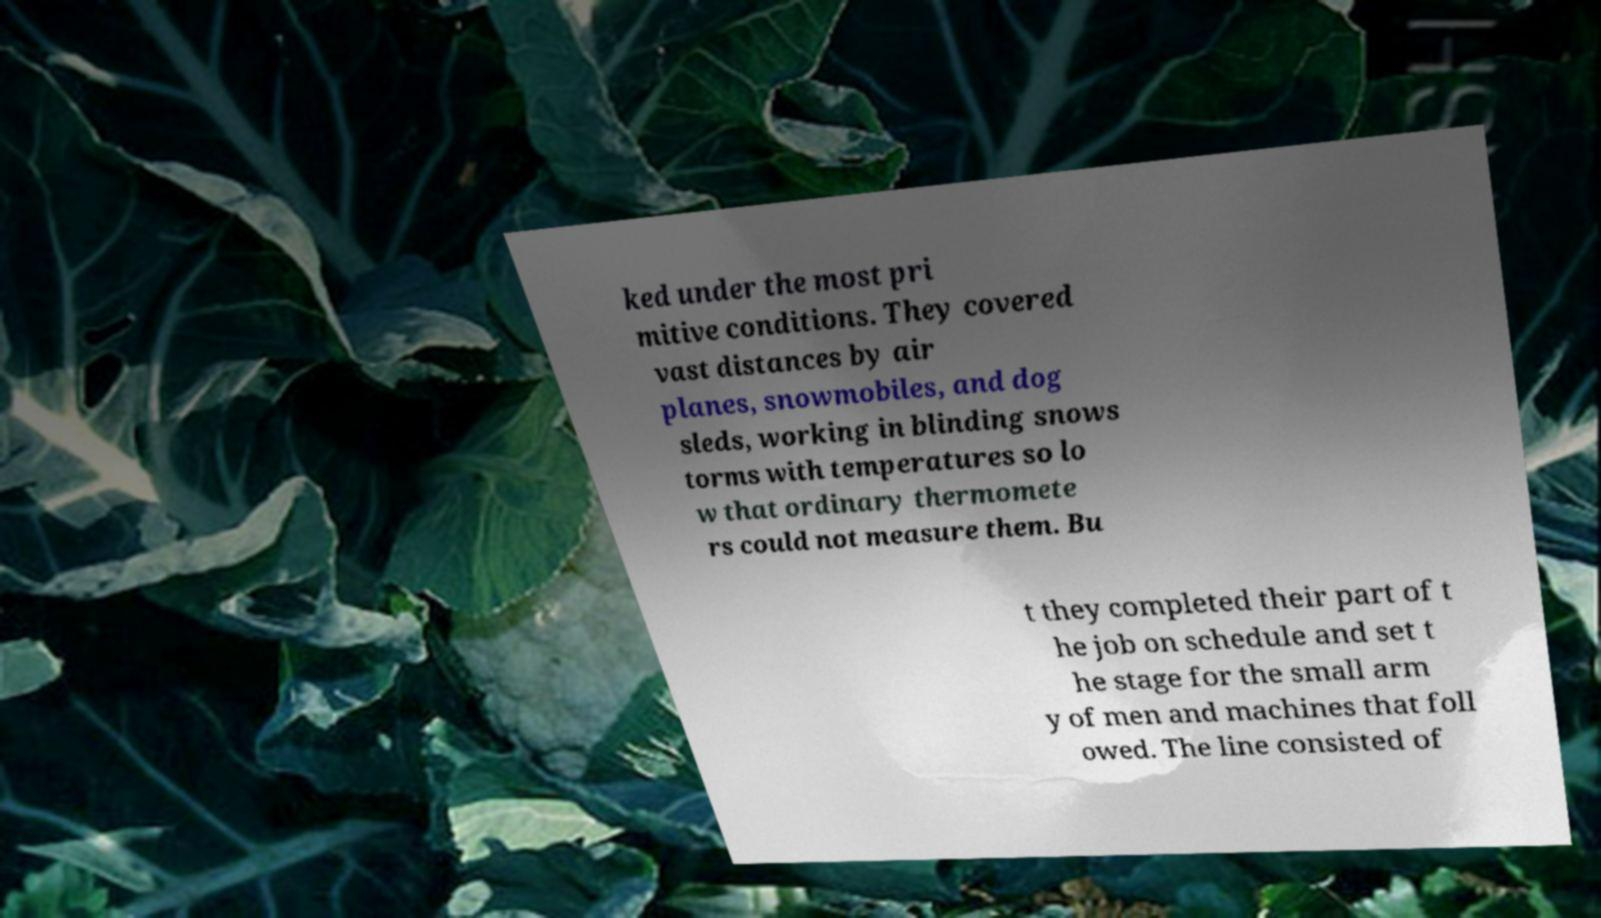Can you read and provide the text displayed in the image?This photo seems to have some interesting text. Can you extract and type it out for me? ked under the most pri mitive conditions. They covered vast distances by air planes, snowmobiles, and dog sleds, working in blinding snows torms with temperatures so lo w that ordinary thermomete rs could not measure them. Bu t they completed their part of t he job on schedule and set t he stage for the small arm y of men and machines that foll owed. The line consisted of 